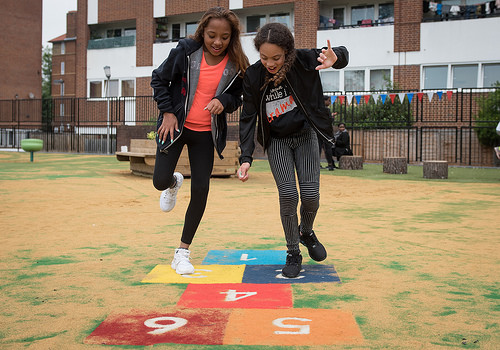<image>
Is there a yellow square under the girl? No. The yellow square is not positioned under the girl. The vertical relationship between these objects is different. Is there a number in front of the shoe? Yes. The number is positioned in front of the shoe, appearing closer to the camera viewpoint. 